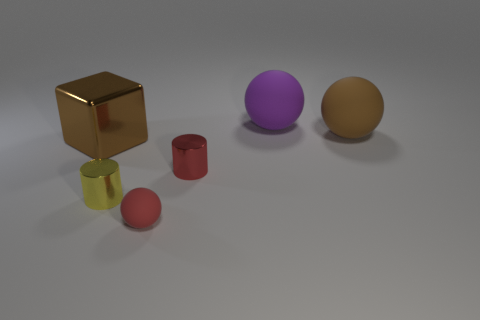What is the material of the cylinder that is the same color as the tiny ball?
Your answer should be very brief. Metal. There is a red cylinder that is the same size as the yellow metallic thing; what material is it?
Your answer should be compact. Metal. Do the yellow object and the large brown block have the same material?
Your answer should be very brief. Yes. How many other tiny cylinders are made of the same material as the red cylinder?
Provide a succinct answer. 1. How many objects are matte objects that are in front of the brown cube or rubber spheres that are right of the small red matte sphere?
Offer a terse response. 3. Are there more metal cubes that are on the left side of the yellow thing than brown blocks that are in front of the brown metallic block?
Provide a short and direct response. Yes. What is the color of the sphere that is in front of the big block?
Provide a succinct answer. Red. Are there any small green metal things of the same shape as the red metal thing?
Your answer should be very brief. No. What number of red objects are either metal things or shiny cylinders?
Offer a very short reply. 1. Are there any brown matte spheres of the same size as the brown metal block?
Keep it short and to the point. Yes. 